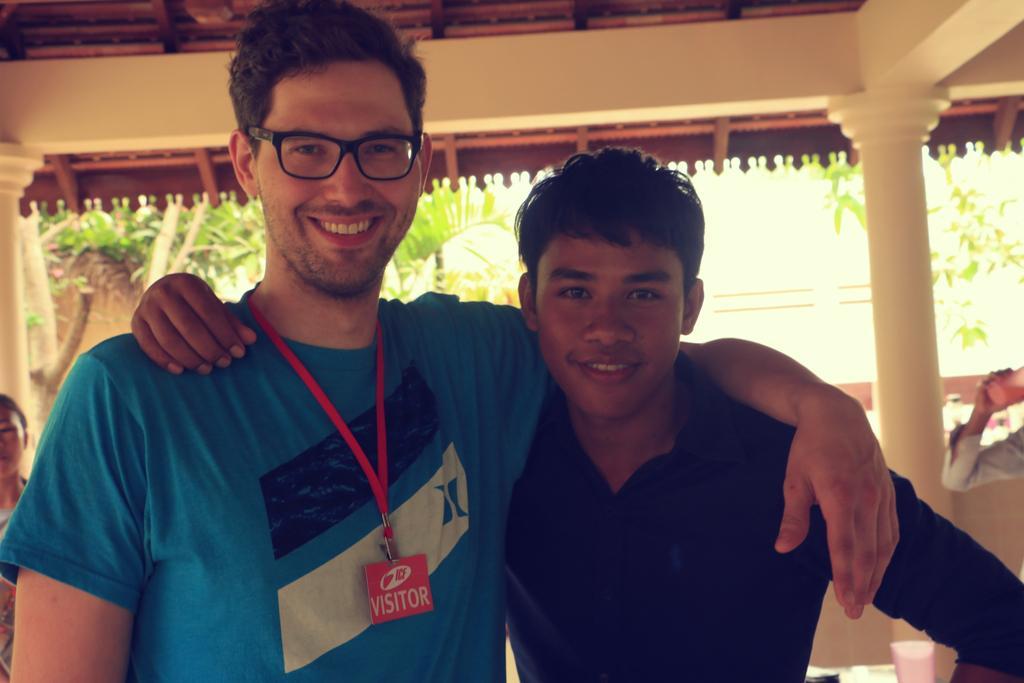Describe this image in one or two sentences. In this image I can see the group of people with different color dresses. I can see one person holding the glass and there is an another glass on the surface. In the background I can see the trees. 